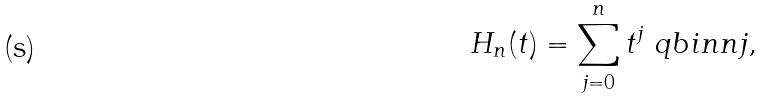<formula> <loc_0><loc_0><loc_500><loc_500>H _ { n } ( t ) = \sum _ { j = 0 } ^ { n } t ^ { j } \ q b i n { n } { j } ,</formula> 